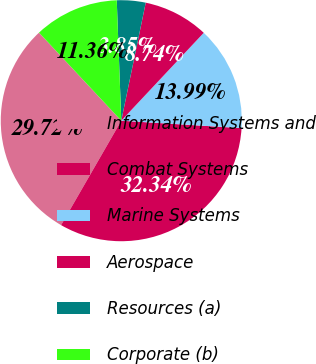Convert chart. <chart><loc_0><loc_0><loc_500><loc_500><pie_chart><fcel>Information Systems and<fcel>Combat Systems<fcel>Marine Systems<fcel>Aerospace<fcel>Resources (a)<fcel>Corporate (b)<nl><fcel>29.72%<fcel>32.34%<fcel>13.99%<fcel>8.74%<fcel>3.85%<fcel>11.36%<nl></chart> 